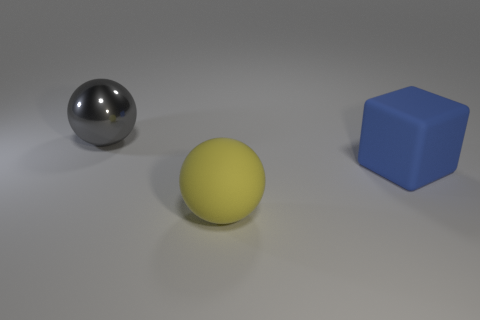There is another object that is the same shape as the gray metal object; what material is it?
Ensure brevity in your answer.  Rubber. Is there any other thing that is the same material as the gray sphere?
Your response must be concise. No. How many other objects are the same shape as the big blue matte thing?
Offer a very short reply. 0. There is a matte object left of the big blue thing; is its shape the same as the rubber thing behind the large yellow object?
Your answer should be very brief. No. How many cylinders are big things or brown rubber objects?
Give a very brief answer. 0. The sphere that is on the right side of the large ball that is left of the large sphere in front of the cube is made of what material?
Offer a very short reply. Rubber. Is the number of gray things behind the yellow matte thing greater than the number of big green blocks?
Offer a terse response. Yes. There is a metallic ball that is the same size as the blue cube; what is its color?
Your response must be concise. Gray. How many large yellow matte things are in front of the sphere in front of the large metallic sphere?
Provide a short and direct response. 0. How many things are big spheres in front of the large gray object or metal cylinders?
Offer a terse response. 1. 